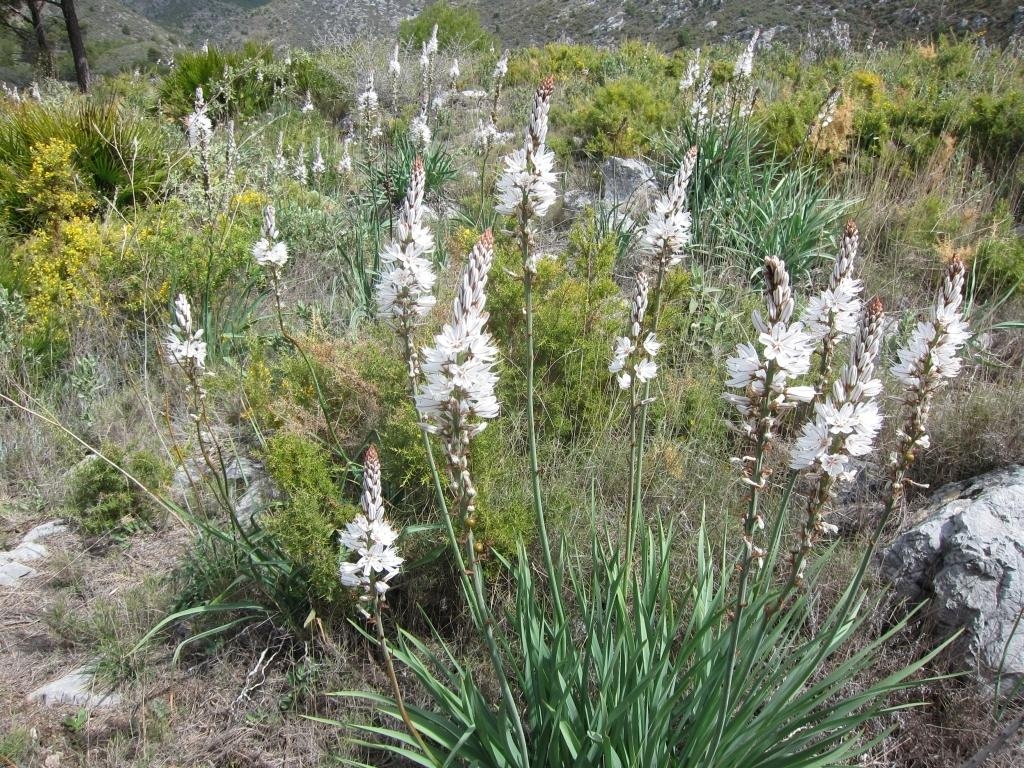What type of vegetation can be seen in the image? There are a lot of plants in the image. What is the ground covered with in the image? There is grass in the image. Are there any specific features of the plants in the image? Some plants have white flowers. What other object can be seen in the image? There is a big stone in the image. Where is the nest located in the image? There is no nest present in the image. What type of tin can be seen in the image? There is no tin present in the image. 